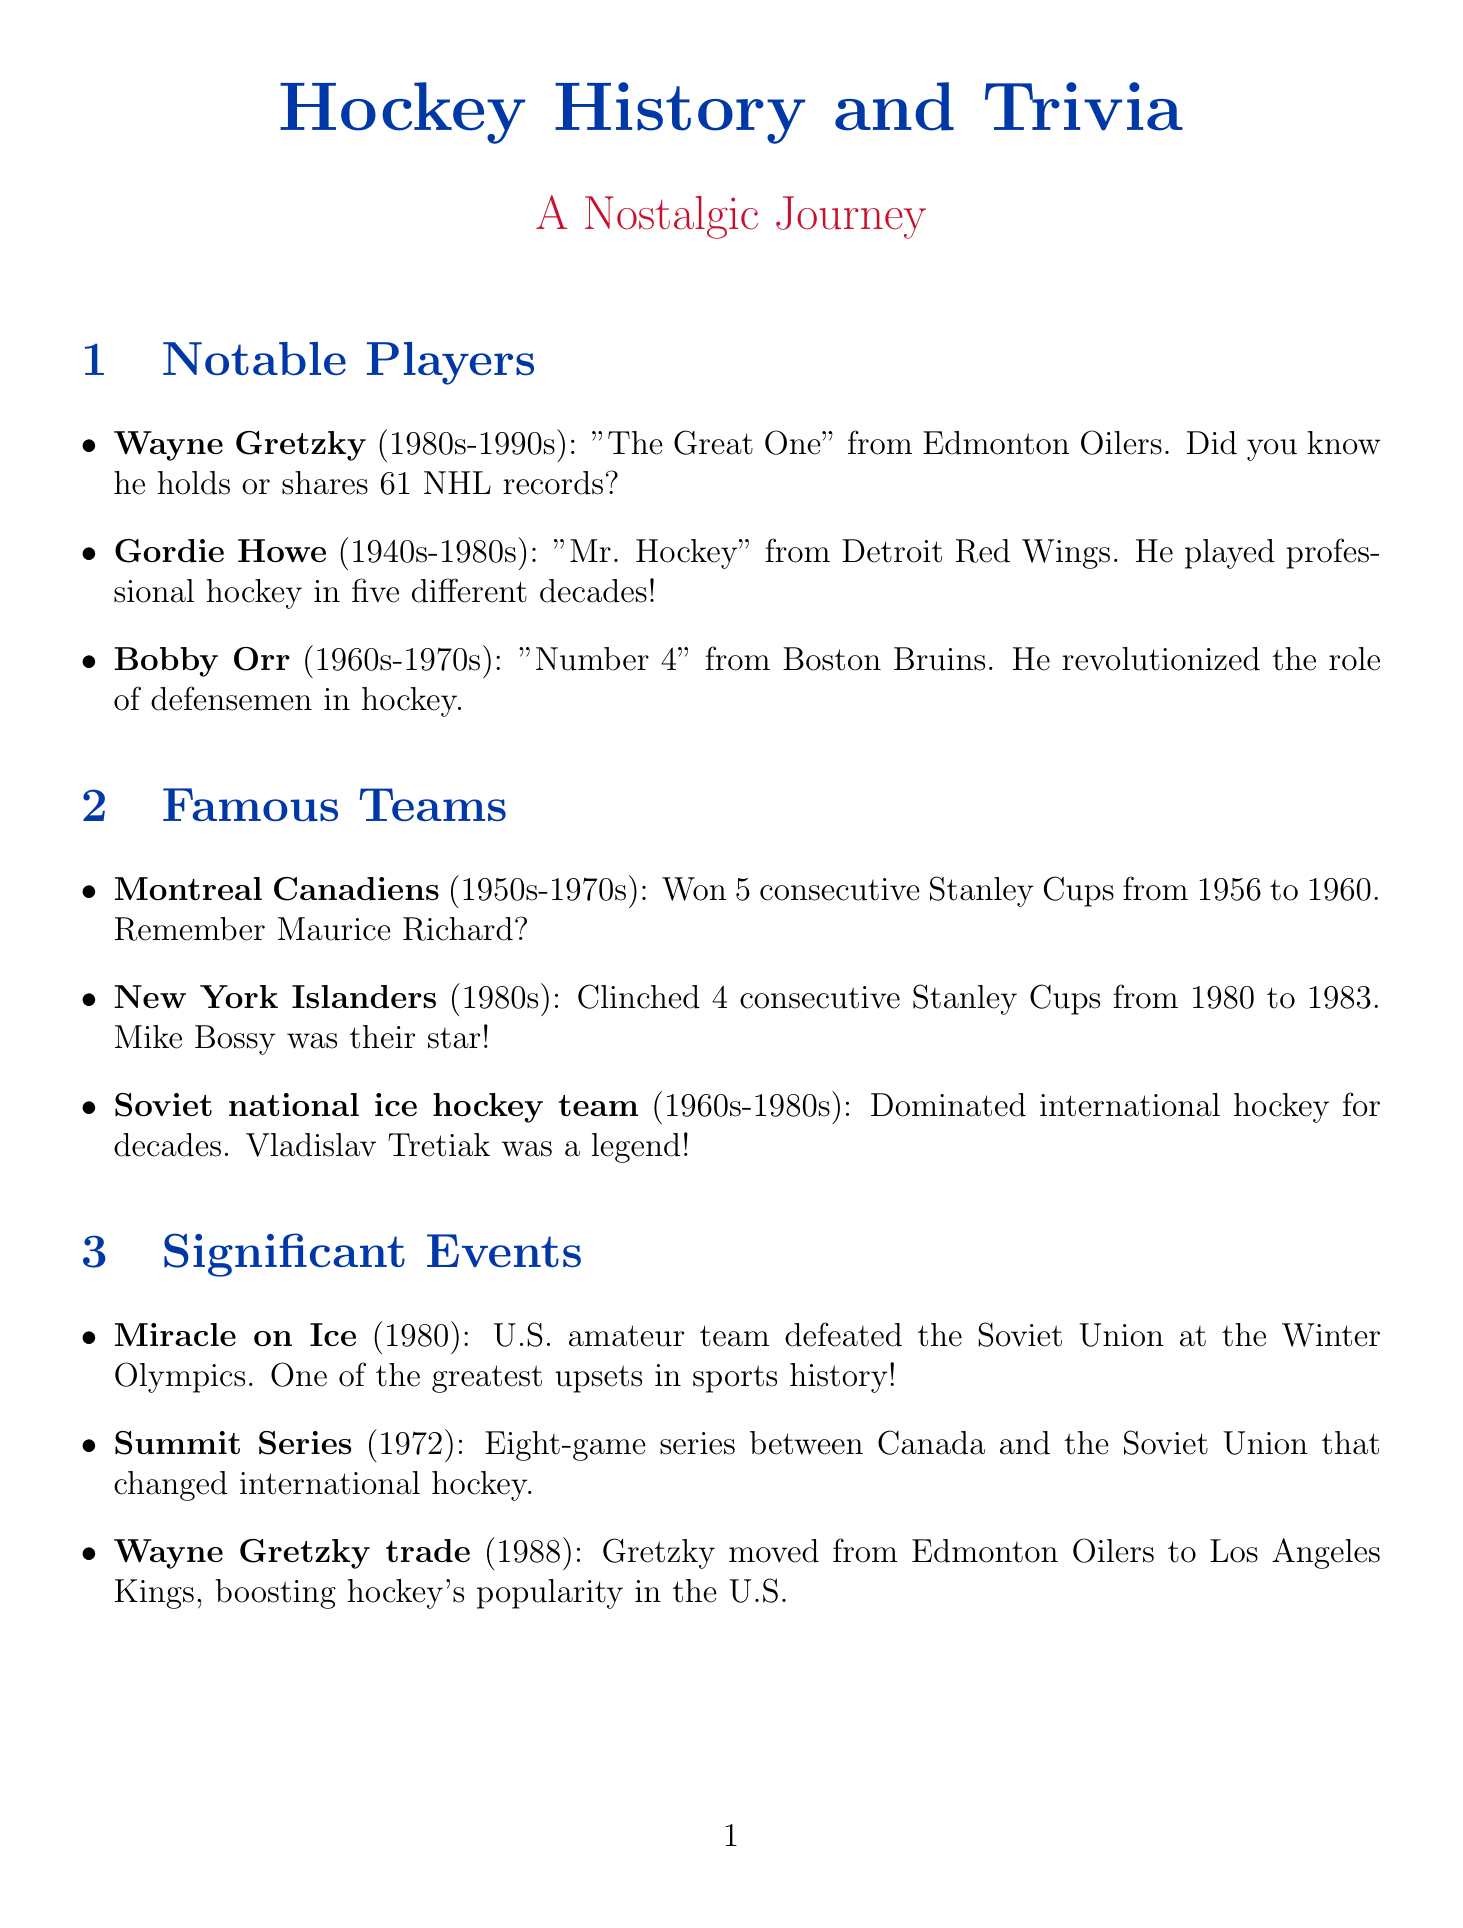What is Wayne Gretzky's nickname? Wayne Gretzky is commonly referred to as "The Great One" in the document.
Answer: The Great One Which team did Gordie Howe play for? Gordie Howe played for the Detroit Red Wings as mentioned in the notable players section.
Answer: Detroit Red Wings How many Stanley Cups did the Montreal Canadiens win consecutively from 1956 to 1960? The document states that the Montreal Canadiens won 5 consecutive Stanley Cups during that period.
Answer: 5 What year did the Miracle on Ice happen? The Miracle on Ice event is dated to 1980 according to the significant events section.
Answer: 1980 Who was a notable player for the New York Islanders? The document highlights Mike Bossy as a notable player for the New York Islanders.
Answer: Mike Bossy What does "hat trick" refer to in hockey? The term "hat trick" is defined in the document as when a player scores three goals in a single game.
Answer: Three goals Which teams are classified as the Original Six? The document lists six teams that made up the NHL from 1942 to 1967 in the hockey terminology section.
Answer: Boston Bruins, Chicago Black Hawks, Detroit Red Wings, Montreal Canadiens, New York Rangers, Toronto Maple Leafs What significant impact did Wayne Gretzky's trade have in 1988? The document states that this trade helped grow hockey's popularity in the United States.
Answer: Hockey's popularity in the United States What decade(s) did Bobby Orr play in? Bobby Orr's playing era is specified in the document as the 1960s-1970s.
Answer: 1960s-1970s 